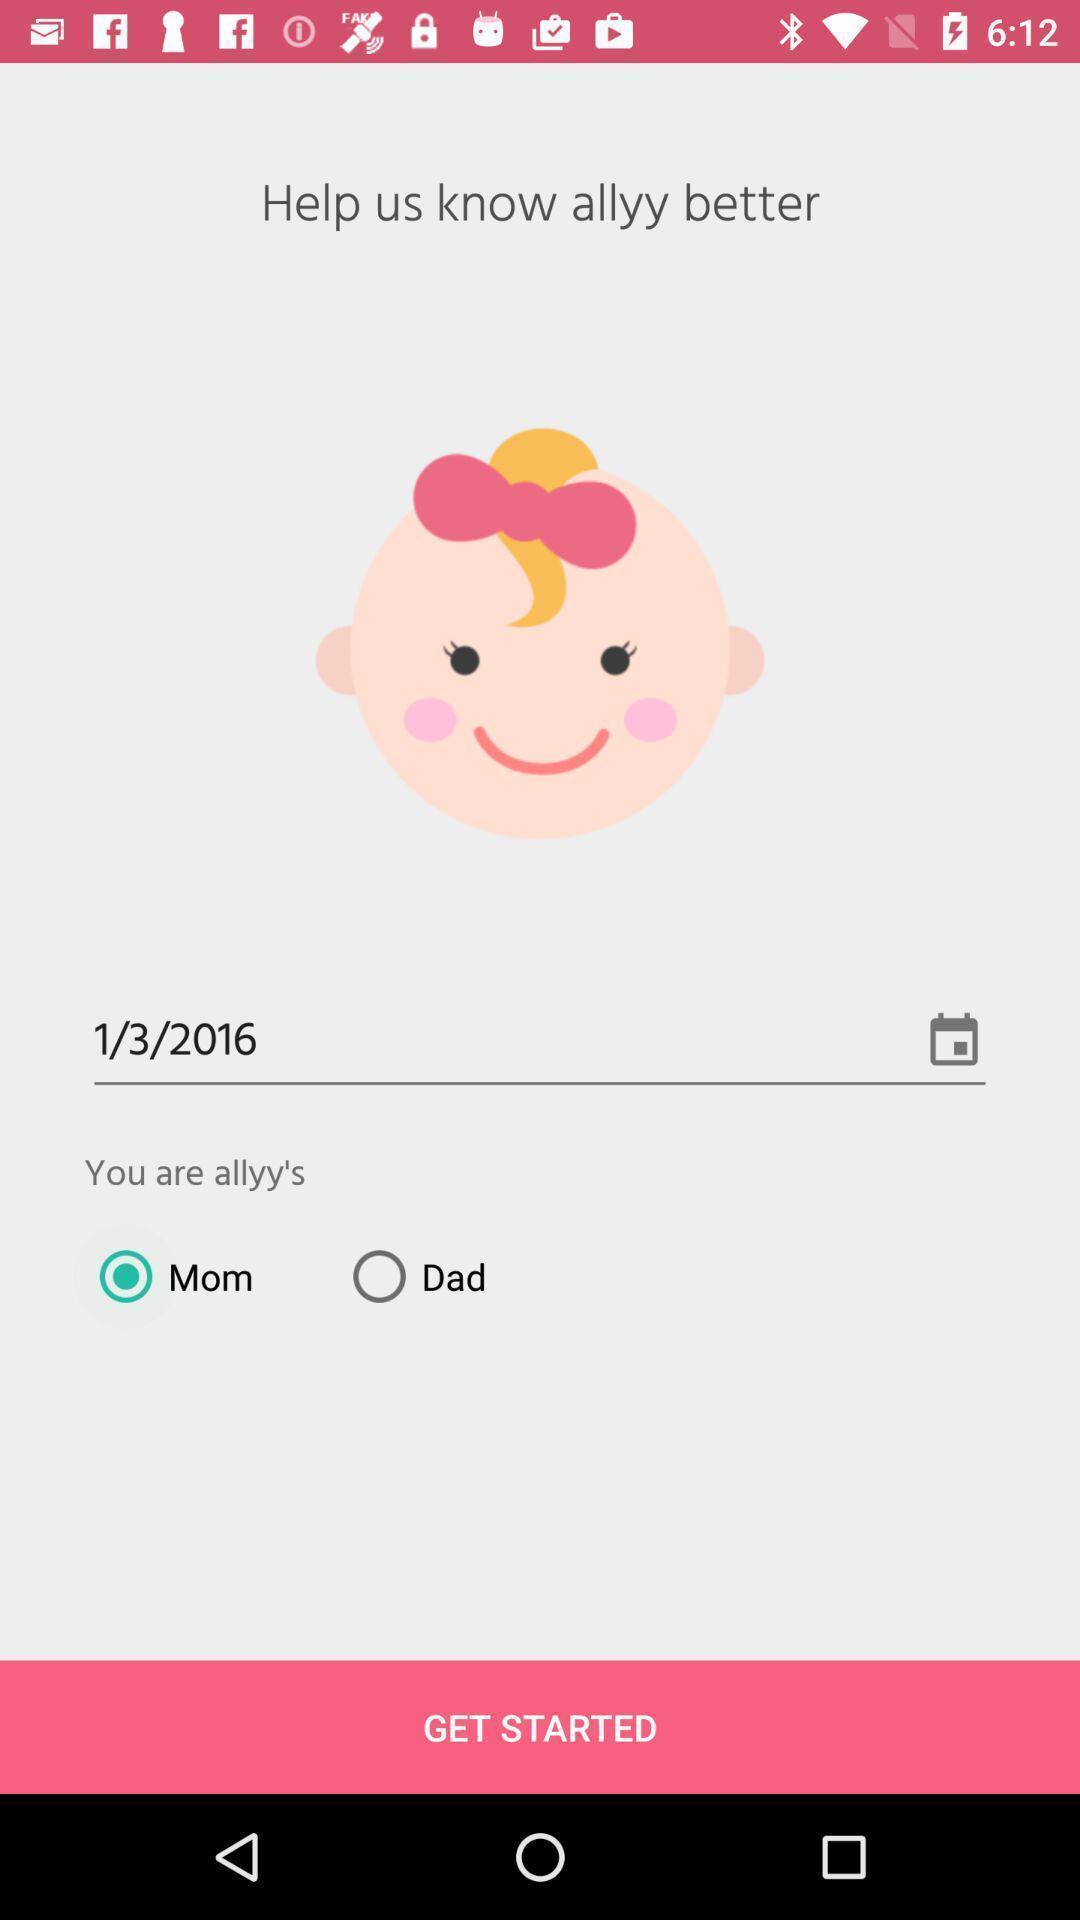Tell me about the visual elements in this screen capture. Welcome page of a social app. 